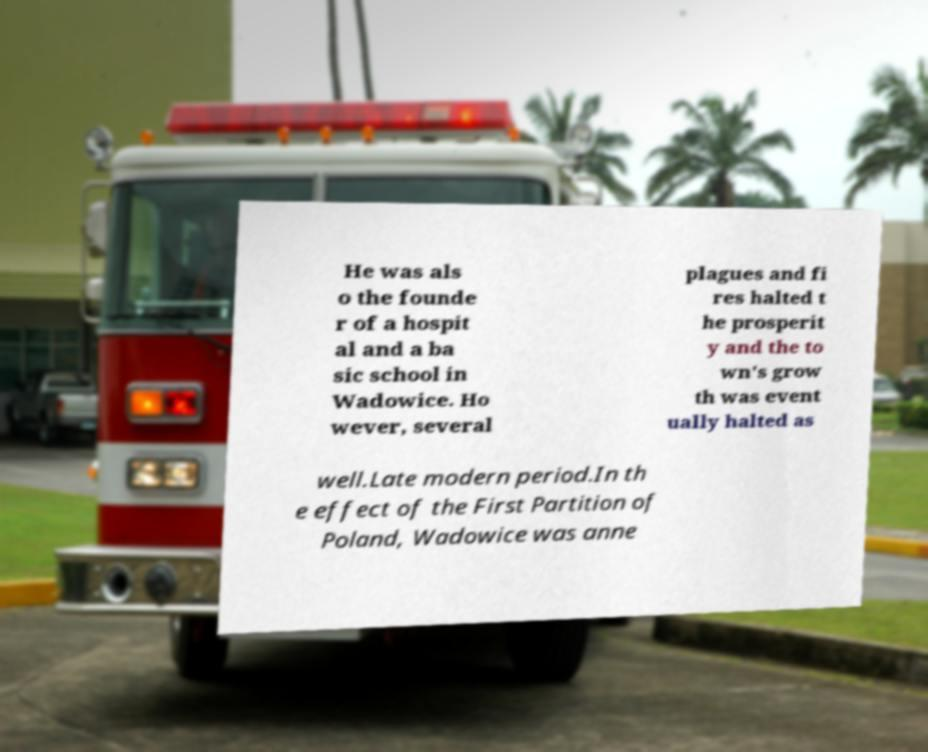For documentation purposes, I need the text within this image transcribed. Could you provide that? He was als o the founde r of a hospit al and a ba sic school in Wadowice. Ho wever, several plagues and fi res halted t he prosperit y and the to wn's grow th was event ually halted as well.Late modern period.In th e effect of the First Partition of Poland, Wadowice was anne 